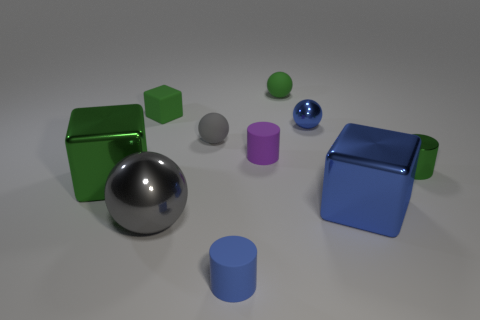Subtract all small rubber cylinders. How many cylinders are left? 1 Subtract 1 green spheres. How many objects are left? 9 Subtract all balls. How many objects are left? 6 Subtract 3 balls. How many balls are left? 1 Subtract all green cylinders. Subtract all green blocks. How many cylinders are left? 2 Subtract all gray cylinders. How many blue cubes are left? 1 Subtract all shiny cylinders. Subtract all tiny metal balls. How many objects are left? 8 Add 4 green shiny things. How many green shiny things are left? 6 Add 7 large blue metallic things. How many large blue metallic things exist? 8 Subtract all green cubes. How many cubes are left? 1 